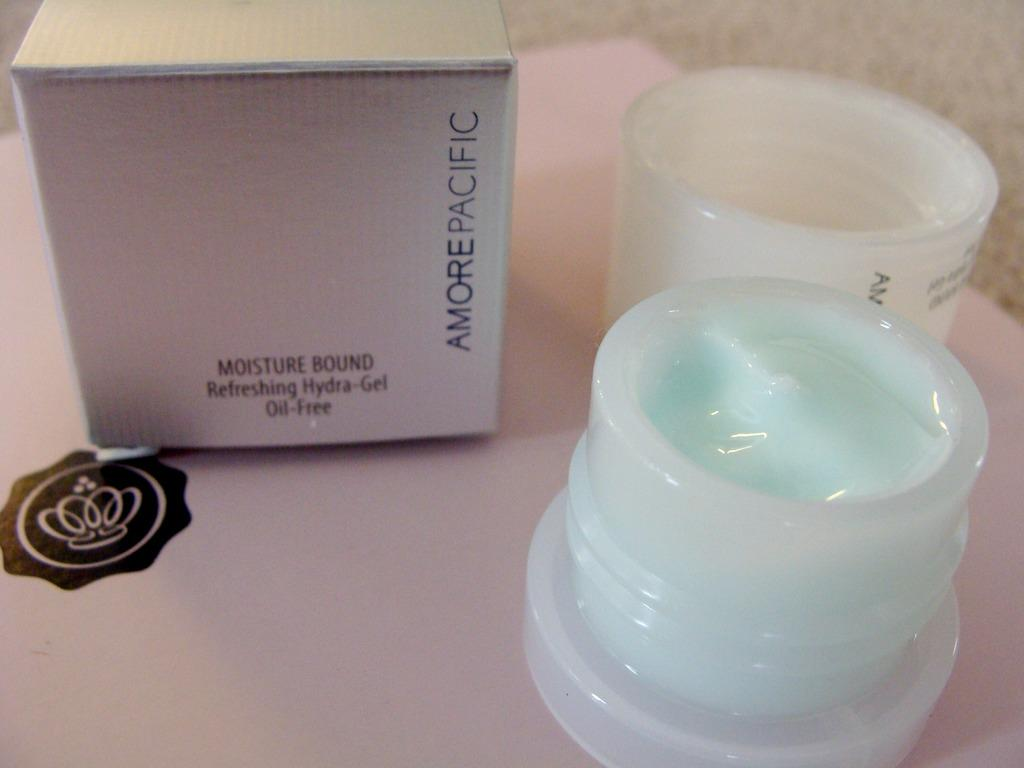Provide a one-sentence caption for the provided image. An opened cosmetic item is on a table next to its box which says that it is oil free. 